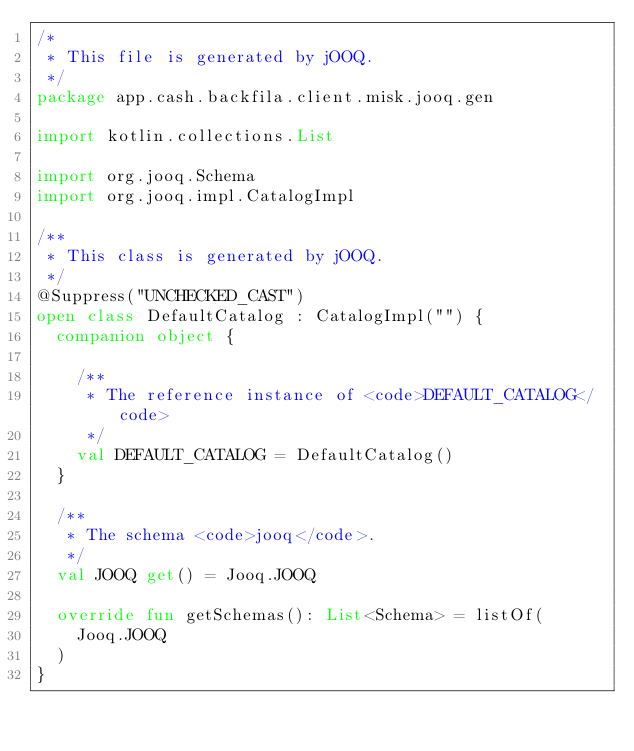<code> <loc_0><loc_0><loc_500><loc_500><_Kotlin_>/*
 * This file is generated by jOOQ.
 */
package app.cash.backfila.client.misk.jooq.gen

import kotlin.collections.List

import org.jooq.Schema
import org.jooq.impl.CatalogImpl

/**
 * This class is generated by jOOQ.
 */
@Suppress("UNCHECKED_CAST")
open class DefaultCatalog : CatalogImpl("") {
  companion object {

    /**
     * The reference instance of <code>DEFAULT_CATALOG</code>
     */
    val DEFAULT_CATALOG = DefaultCatalog()
  }

  /**
   * The schema <code>jooq</code>.
   */
  val JOOQ get() = Jooq.JOOQ

  override fun getSchemas(): List<Schema> = listOf(
    Jooq.JOOQ
  )
}
</code> 